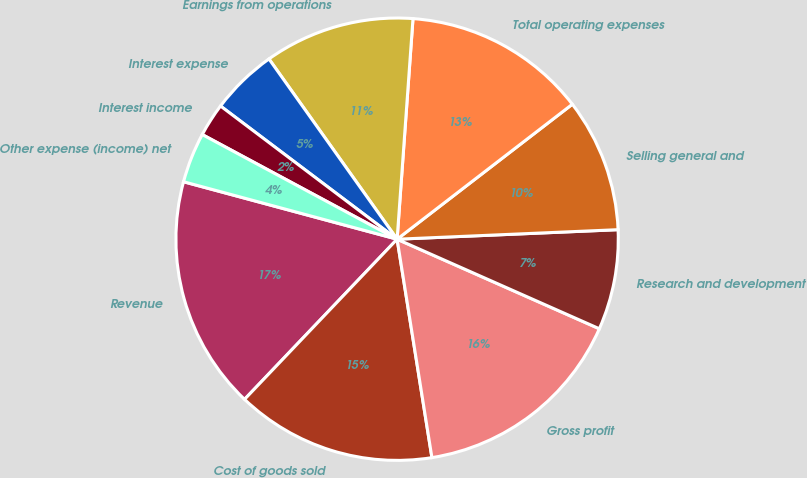Convert chart to OTSL. <chart><loc_0><loc_0><loc_500><loc_500><pie_chart><fcel>Revenue<fcel>Cost of goods sold<fcel>Gross profit<fcel>Research and development<fcel>Selling general and<fcel>Total operating expenses<fcel>Earnings from operations<fcel>Interest expense<fcel>Interest income<fcel>Other expense (income) net<nl><fcel>17.07%<fcel>14.63%<fcel>15.85%<fcel>7.32%<fcel>9.76%<fcel>13.41%<fcel>10.98%<fcel>4.88%<fcel>2.44%<fcel>3.66%<nl></chart> 